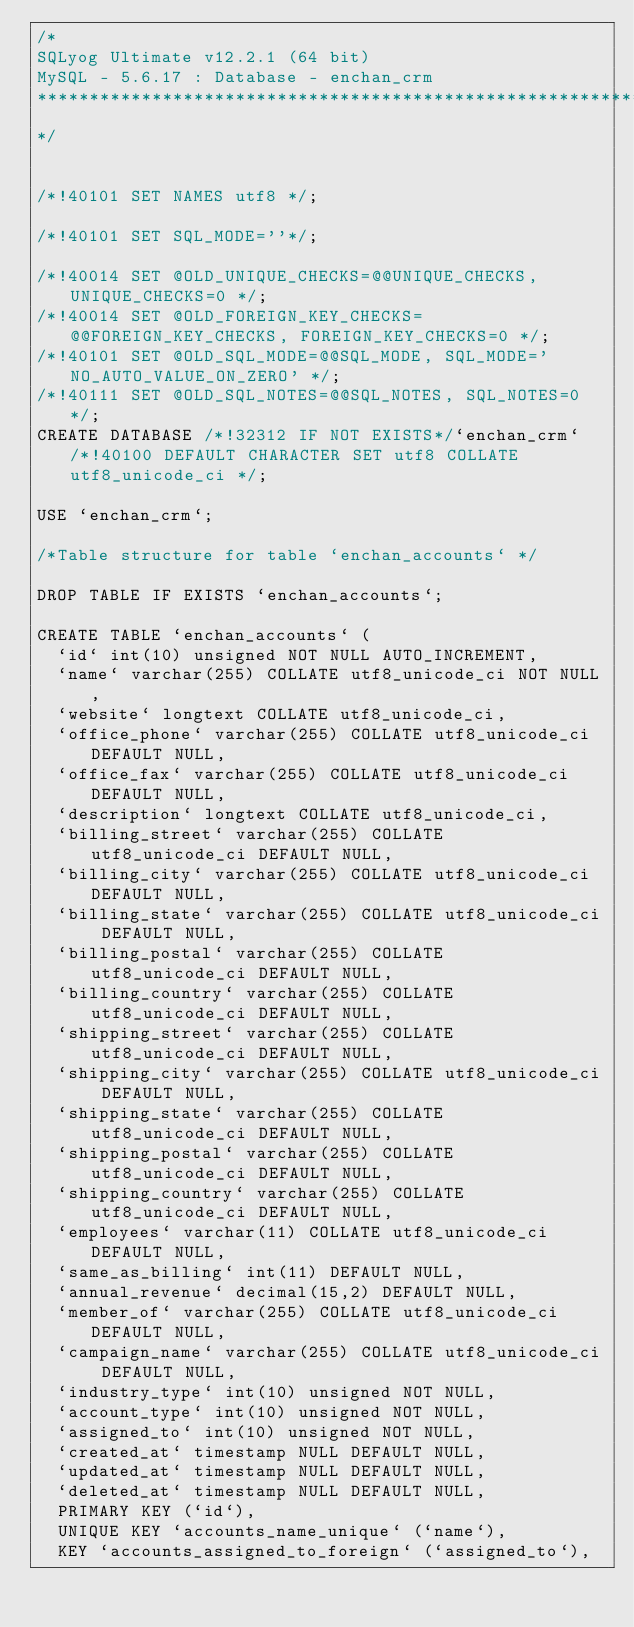<code> <loc_0><loc_0><loc_500><loc_500><_SQL_>/*
SQLyog Ultimate v12.2.1 (64 bit)
MySQL - 5.6.17 : Database - enchan_crm
*********************************************************************
*/

/*!40101 SET NAMES utf8 */;

/*!40101 SET SQL_MODE=''*/;

/*!40014 SET @OLD_UNIQUE_CHECKS=@@UNIQUE_CHECKS, UNIQUE_CHECKS=0 */;
/*!40014 SET @OLD_FOREIGN_KEY_CHECKS=@@FOREIGN_KEY_CHECKS, FOREIGN_KEY_CHECKS=0 */;
/*!40101 SET @OLD_SQL_MODE=@@SQL_MODE, SQL_MODE='NO_AUTO_VALUE_ON_ZERO' */;
/*!40111 SET @OLD_SQL_NOTES=@@SQL_NOTES, SQL_NOTES=0 */;
CREATE DATABASE /*!32312 IF NOT EXISTS*/`enchan_crm` /*!40100 DEFAULT CHARACTER SET utf8 COLLATE utf8_unicode_ci */;

USE `enchan_crm`;

/*Table structure for table `enchan_accounts` */

DROP TABLE IF EXISTS `enchan_accounts`;

CREATE TABLE `enchan_accounts` (
  `id` int(10) unsigned NOT NULL AUTO_INCREMENT,
  `name` varchar(255) COLLATE utf8_unicode_ci NOT NULL,
  `website` longtext COLLATE utf8_unicode_ci,
  `office_phone` varchar(255) COLLATE utf8_unicode_ci DEFAULT NULL,
  `office_fax` varchar(255) COLLATE utf8_unicode_ci DEFAULT NULL,
  `description` longtext COLLATE utf8_unicode_ci,
  `billing_street` varchar(255) COLLATE utf8_unicode_ci DEFAULT NULL,
  `billing_city` varchar(255) COLLATE utf8_unicode_ci DEFAULT NULL,
  `billing_state` varchar(255) COLLATE utf8_unicode_ci DEFAULT NULL,
  `billing_postal` varchar(255) COLLATE utf8_unicode_ci DEFAULT NULL,
  `billing_country` varchar(255) COLLATE utf8_unicode_ci DEFAULT NULL,
  `shipping_street` varchar(255) COLLATE utf8_unicode_ci DEFAULT NULL,
  `shipping_city` varchar(255) COLLATE utf8_unicode_ci DEFAULT NULL,
  `shipping_state` varchar(255) COLLATE utf8_unicode_ci DEFAULT NULL,
  `shipping_postal` varchar(255) COLLATE utf8_unicode_ci DEFAULT NULL,
  `shipping_country` varchar(255) COLLATE utf8_unicode_ci DEFAULT NULL,
  `employees` varchar(11) COLLATE utf8_unicode_ci DEFAULT NULL,
  `same_as_billing` int(11) DEFAULT NULL,
  `annual_revenue` decimal(15,2) DEFAULT NULL,
  `member_of` varchar(255) COLLATE utf8_unicode_ci DEFAULT NULL,
  `campaign_name` varchar(255) COLLATE utf8_unicode_ci DEFAULT NULL,
  `industry_type` int(10) unsigned NOT NULL,
  `account_type` int(10) unsigned NOT NULL,
  `assigned_to` int(10) unsigned NOT NULL,
  `created_at` timestamp NULL DEFAULT NULL,
  `updated_at` timestamp NULL DEFAULT NULL,
  `deleted_at` timestamp NULL DEFAULT NULL,
  PRIMARY KEY (`id`),
  UNIQUE KEY `accounts_name_unique` (`name`),
  KEY `accounts_assigned_to_foreign` (`assigned_to`),</code> 